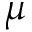<formula> <loc_0><loc_0><loc_500><loc_500>\mu</formula> 